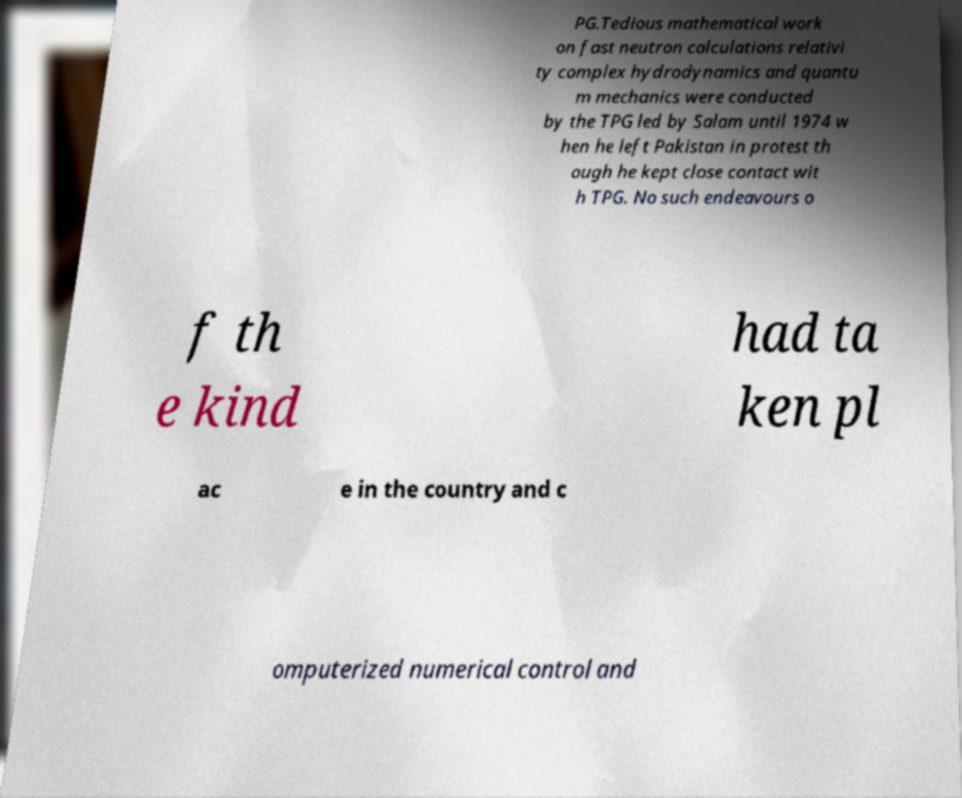Please read and relay the text visible in this image. What does it say? PG.Tedious mathematical work on fast neutron calculations relativi ty complex hydrodynamics and quantu m mechanics were conducted by the TPG led by Salam until 1974 w hen he left Pakistan in protest th ough he kept close contact wit h TPG. No such endeavours o f th e kind had ta ken pl ac e in the country and c omputerized numerical control and 